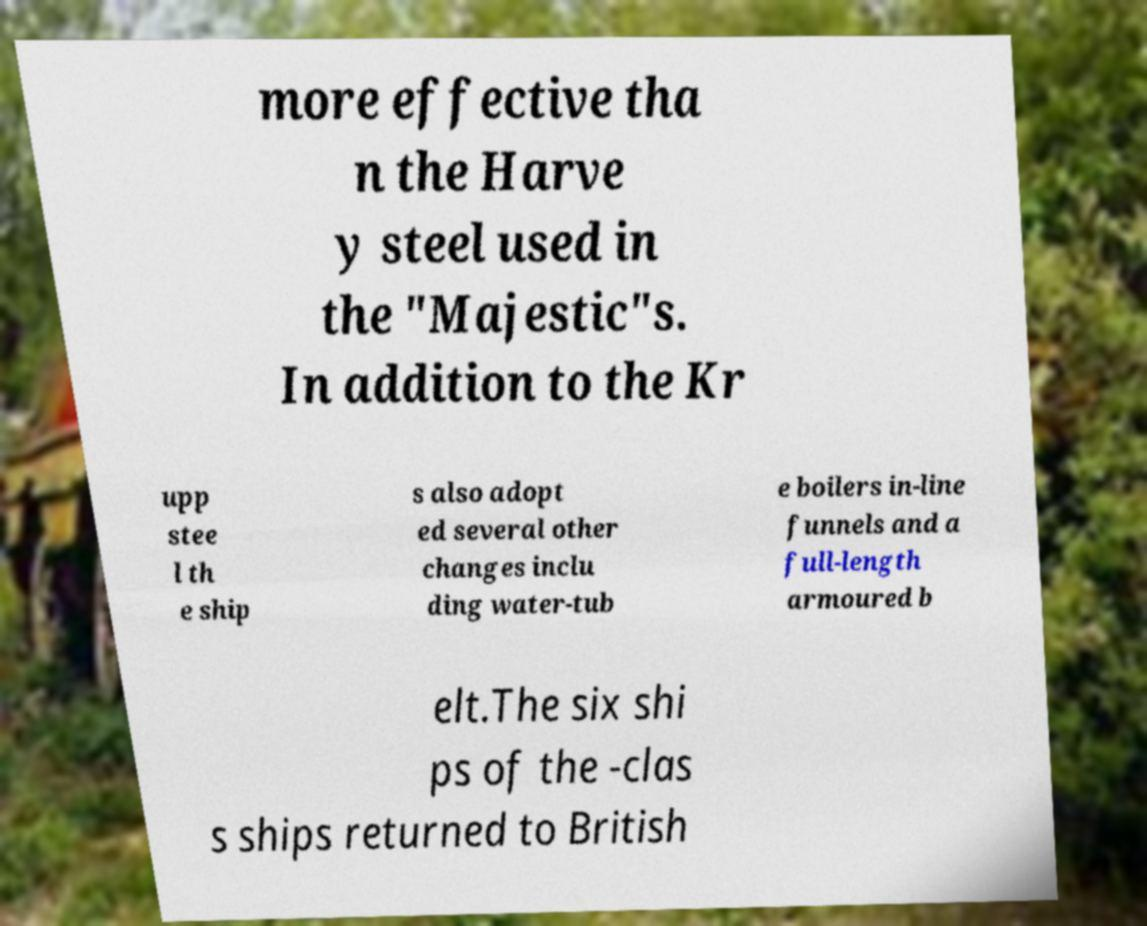What messages or text are displayed in this image? I need them in a readable, typed format. more effective tha n the Harve y steel used in the "Majestic"s. In addition to the Kr upp stee l th e ship s also adopt ed several other changes inclu ding water-tub e boilers in-line funnels and a full-length armoured b elt.The six shi ps of the -clas s ships returned to British 